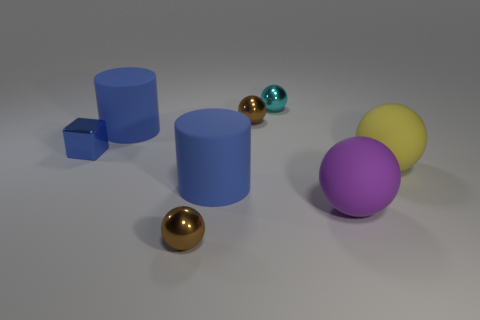Add 2 cyan metal things. How many objects exist? 10 Subtract all cyan metallic balls. How many balls are left? 4 Subtract all yellow spheres. How many spheres are left? 4 Subtract 1 blocks. How many blocks are left? 0 Subtract all blue balls. Subtract all purple blocks. How many balls are left? 5 Subtract all blue spheres. How many red cubes are left? 0 Subtract all red cylinders. Subtract all shiny things. How many objects are left? 4 Add 5 big purple balls. How many big purple balls are left? 6 Add 2 large blue cylinders. How many large blue cylinders exist? 4 Subtract 0 green blocks. How many objects are left? 8 